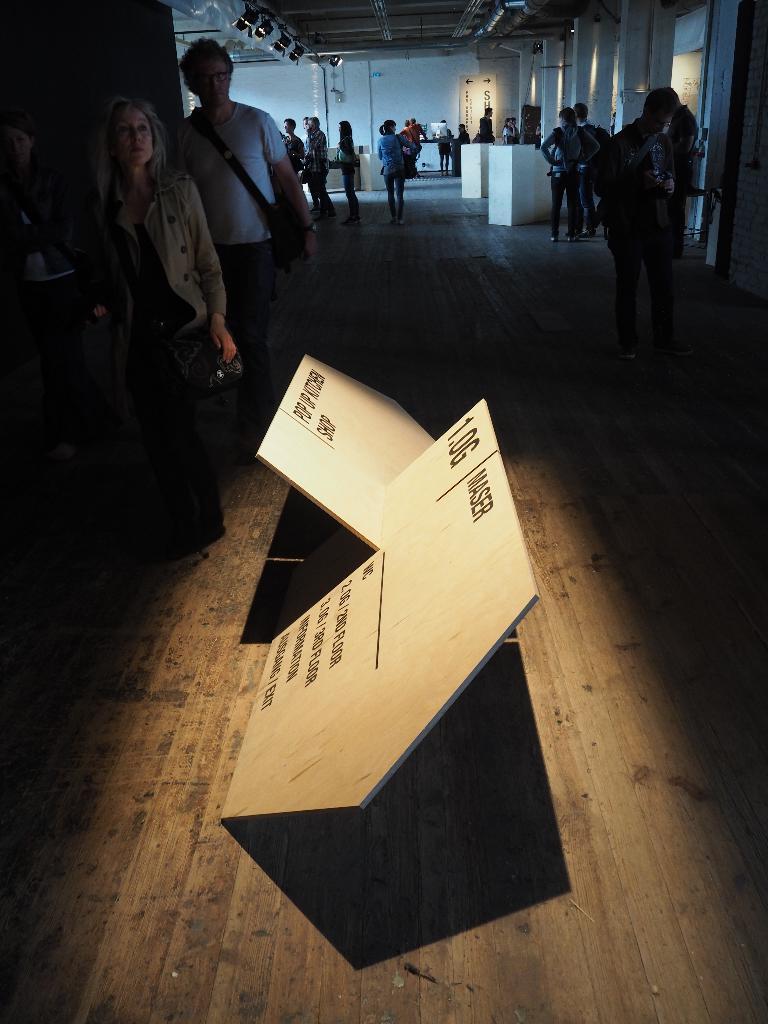Can you describe this image briefly? In the center of the image there are boards with some text. There are people walking. At the bottom of the image there is wooden flooring. In the background of the image there is wall. At the top of the image there is ceiling with lights. 